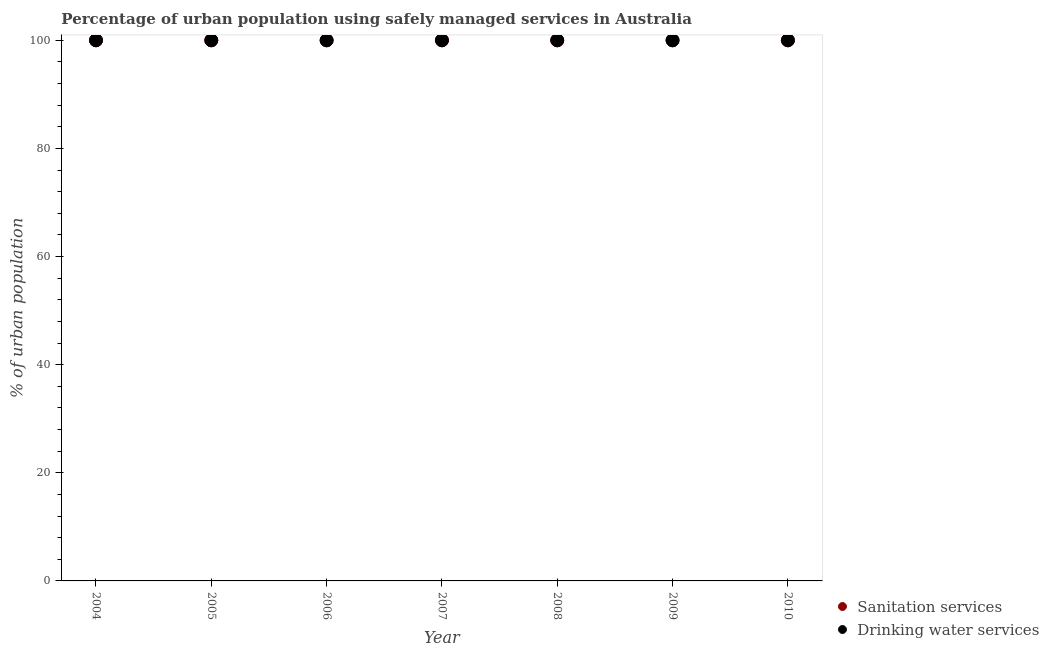Is the number of dotlines equal to the number of legend labels?
Give a very brief answer. Yes. What is the percentage of urban population who used sanitation services in 2008?
Your response must be concise. 100. Across all years, what is the maximum percentage of urban population who used sanitation services?
Provide a succinct answer. 100. Across all years, what is the minimum percentage of urban population who used sanitation services?
Keep it short and to the point. 100. In which year was the percentage of urban population who used sanitation services maximum?
Ensure brevity in your answer.  2004. In which year was the percentage of urban population who used drinking water services minimum?
Offer a terse response. 2004. What is the total percentage of urban population who used sanitation services in the graph?
Give a very brief answer. 700. What is the average percentage of urban population who used sanitation services per year?
Your response must be concise. 100. In the year 2005, what is the difference between the percentage of urban population who used drinking water services and percentage of urban population who used sanitation services?
Provide a short and direct response. 0. In how many years, is the percentage of urban population who used sanitation services greater than 56 %?
Your answer should be very brief. 7. Is the percentage of urban population who used drinking water services in 2006 less than that in 2010?
Provide a succinct answer. No. Is the percentage of urban population who used sanitation services strictly greater than the percentage of urban population who used drinking water services over the years?
Keep it short and to the point. No. Is the percentage of urban population who used sanitation services strictly less than the percentage of urban population who used drinking water services over the years?
Offer a terse response. No. How many dotlines are there?
Offer a terse response. 2. How many years are there in the graph?
Your response must be concise. 7. What is the difference between two consecutive major ticks on the Y-axis?
Make the answer very short. 20. Are the values on the major ticks of Y-axis written in scientific E-notation?
Keep it short and to the point. No. Does the graph contain grids?
Make the answer very short. No. Where does the legend appear in the graph?
Provide a succinct answer. Bottom right. How many legend labels are there?
Make the answer very short. 2. How are the legend labels stacked?
Provide a short and direct response. Vertical. What is the title of the graph?
Your answer should be very brief. Percentage of urban population using safely managed services in Australia. Does "External balance on goods" appear as one of the legend labels in the graph?
Your answer should be very brief. No. What is the label or title of the Y-axis?
Your response must be concise. % of urban population. What is the % of urban population of Sanitation services in 2005?
Provide a short and direct response. 100. What is the % of urban population of Drinking water services in 2007?
Provide a short and direct response. 100. What is the % of urban population of Sanitation services in 2009?
Provide a short and direct response. 100. What is the % of urban population in Drinking water services in 2009?
Offer a terse response. 100. What is the % of urban population of Sanitation services in 2010?
Keep it short and to the point. 100. Across all years, what is the maximum % of urban population in Drinking water services?
Ensure brevity in your answer.  100. Across all years, what is the minimum % of urban population of Sanitation services?
Make the answer very short. 100. What is the total % of urban population of Sanitation services in the graph?
Offer a terse response. 700. What is the total % of urban population in Drinking water services in the graph?
Your answer should be very brief. 700. What is the difference between the % of urban population of Sanitation services in 2004 and that in 2007?
Ensure brevity in your answer.  0. What is the difference between the % of urban population of Drinking water services in 2004 and that in 2007?
Ensure brevity in your answer.  0. What is the difference between the % of urban population in Sanitation services in 2004 and that in 2008?
Give a very brief answer. 0. What is the difference between the % of urban population of Sanitation services in 2004 and that in 2009?
Offer a terse response. 0. What is the difference between the % of urban population of Drinking water services in 2004 and that in 2009?
Your answer should be compact. 0. What is the difference between the % of urban population of Sanitation services in 2004 and that in 2010?
Offer a terse response. 0. What is the difference between the % of urban population in Drinking water services in 2005 and that in 2006?
Provide a succinct answer. 0. What is the difference between the % of urban population in Drinking water services in 2005 and that in 2007?
Provide a succinct answer. 0. What is the difference between the % of urban population of Sanitation services in 2005 and that in 2008?
Provide a succinct answer. 0. What is the difference between the % of urban population of Drinking water services in 2005 and that in 2008?
Your answer should be very brief. 0. What is the difference between the % of urban population in Sanitation services in 2005 and that in 2009?
Keep it short and to the point. 0. What is the difference between the % of urban population of Sanitation services in 2005 and that in 2010?
Provide a succinct answer. 0. What is the difference between the % of urban population in Drinking water services in 2005 and that in 2010?
Provide a succinct answer. 0. What is the difference between the % of urban population in Sanitation services in 2006 and that in 2008?
Ensure brevity in your answer.  0. What is the difference between the % of urban population in Drinking water services in 2006 and that in 2008?
Ensure brevity in your answer.  0. What is the difference between the % of urban population in Sanitation services in 2006 and that in 2009?
Your response must be concise. 0. What is the difference between the % of urban population in Drinking water services in 2006 and that in 2009?
Offer a terse response. 0. What is the difference between the % of urban population in Sanitation services in 2007 and that in 2010?
Give a very brief answer. 0. What is the difference between the % of urban population in Drinking water services in 2007 and that in 2010?
Offer a terse response. 0. What is the difference between the % of urban population of Sanitation services in 2008 and that in 2010?
Provide a short and direct response. 0. What is the difference between the % of urban population of Drinking water services in 2009 and that in 2010?
Your response must be concise. 0. What is the difference between the % of urban population of Sanitation services in 2004 and the % of urban population of Drinking water services in 2005?
Your answer should be very brief. 0. What is the difference between the % of urban population of Sanitation services in 2004 and the % of urban population of Drinking water services in 2006?
Your response must be concise. 0. What is the difference between the % of urban population of Sanitation services in 2004 and the % of urban population of Drinking water services in 2008?
Provide a short and direct response. 0. What is the difference between the % of urban population of Sanitation services in 2004 and the % of urban population of Drinking water services in 2009?
Provide a short and direct response. 0. What is the difference between the % of urban population of Sanitation services in 2004 and the % of urban population of Drinking water services in 2010?
Make the answer very short. 0. What is the difference between the % of urban population of Sanitation services in 2005 and the % of urban population of Drinking water services in 2007?
Your answer should be very brief. 0. What is the difference between the % of urban population in Sanitation services in 2006 and the % of urban population in Drinking water services in 2010?
Give a very brief answer. 0. What is the difference between the % of urban population of Sanitation services in 2008 and the % of urban population of Drinking water services in 2009?
Keep it short and to the point. 0. What is the average % of urban population of Sanitation services per year?
Provide a short and direct response. 100. What is the average % of urban population in Drinking water services per year?
Provide a short and direct response. 100. In the year 2004, what is the difference between the % of urban population of Sanitation services and % of urban population of Drinking water services?
Provide a short and direct response. 0. In the year 2005, what is the difference between the % of urban population of Sanitation services and % of urban population of Drinking water services?
Give a very brief answer. 0. In the year 2006, what is the difference between the % of urban population in Sanitation services and % of urban population in Drinking water services?
Make the answer very short. 0. In the year 2008, what is the difference between the % of urban population of Sanitation services and % of urban population of Drinking water services?
Ensure brevity in your answer.  0. In the year 2009, what is the difference between the % of urban population of Sanitation services and % of urban population of Drinking water services?
Your response must be concise. 0. In the year 2010, what is the difference between the % of urban population of Sanitation services and % of urban population of Drinking water services?
Provide a short and direct response. 0. What is the ratio of the % of urban population of Sanitation services in 2004 to that in 2005?
Offer a terse response. 1. What is the ratio of the % of urban population of Drinking water services in 2004 to that in 2005?
Provide a short and direct response. 1. What is the ratio of the % of urban population in Sanitation services in 2004 to that in 2006?
Keep it short and to the point. 1. What is the ratio of the % of urban population in Drinking water services in 2004 to that in 2006?
Ensure brevity in your answer.  1. What is the ratio of the % of urban population of Sanitation services in 2004 to that in 2008?
Offer a terse response. 1. What is the ratio of the % of urban population in Drinking water services in 2004 to that in 2008?
Provide a succinct answer. 1. What is the ratio of the % of urban population of Sanitation services in 2004 to that in 2009?
Offer a terse response. 1. What is the ratio of the % of urban population of Drinking water services in 2004 to that in 2009?
Offer a very short reply. 1. What is the ratio of the % of urban population of Sanitation services in 2005 to that in 2007?
Your answer should be very brief. 1. What is the ratio of the % of urban population of Drinking water services in 2005 to that in 2007?
Your response must be concise. 1. What is the ratio of the % of urban population of Sanitation services in 2005 to that in 2008?
Keep it short and to the point. 1. What is the ratio of the % of urban population of Drinking water services in 2005 to that in 2008?
Your answer should be compact. 1. What is the ratio of the % of urban population of Sanitation services in 2005 to that in 2009?
Give a very brief answer. 1. What is the ratio of the % of urban population of Drinking water services in 2005 to that in 2009?
Keep it short and to the point. 1. What is the ratio of the % of urban population in Drinking water services in 2005 to that in 2010?
Give a very brief answer. 1. What is the ratio of the % of urban population in Drinking water services in 2006 to that in 2007?
Provide a short and direct response. 1. What is the ratio of the % of urban population in Drinking water services in 2006 to that in 2009?
Your answer should be compact. 1. What is the ratio of the % of urban population of Sanitation services in 2007 to that in 2008?
Your answer should be very brief. 1. What is the ratio of the % of urban population of Sanitation services in 2007 to that in 2009?
Your response must be concise. 1. What is the ratio of the % of urban population in Drinking water services in 2007 to that in 2009?
Give a very brief answer. 1. What is the ratio of the % of urban population of Drinking water services in 2007 to that in 2010?
Give a very brief answer. 1. What is the ratio of the % of urban population of Sanitation services in 2008 to that in 2009?
Make the answer very short. 1. What is the ratio of the % of urban population in Drinking water services in 2008 to that in 2009?
Make the answer very short. 1. What is the ratio of the % of urban population in Drinking water services in 2009 to that in 2010?
Offer a very short reply. 1. What is the difference between the highest and the second highest % of urban population of Drinking water services?
Offer a very short reply. 0. 